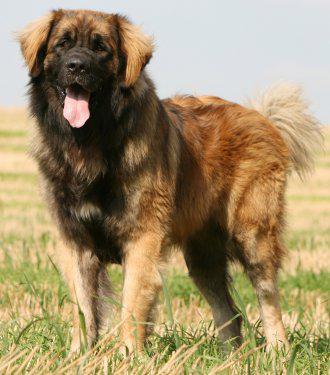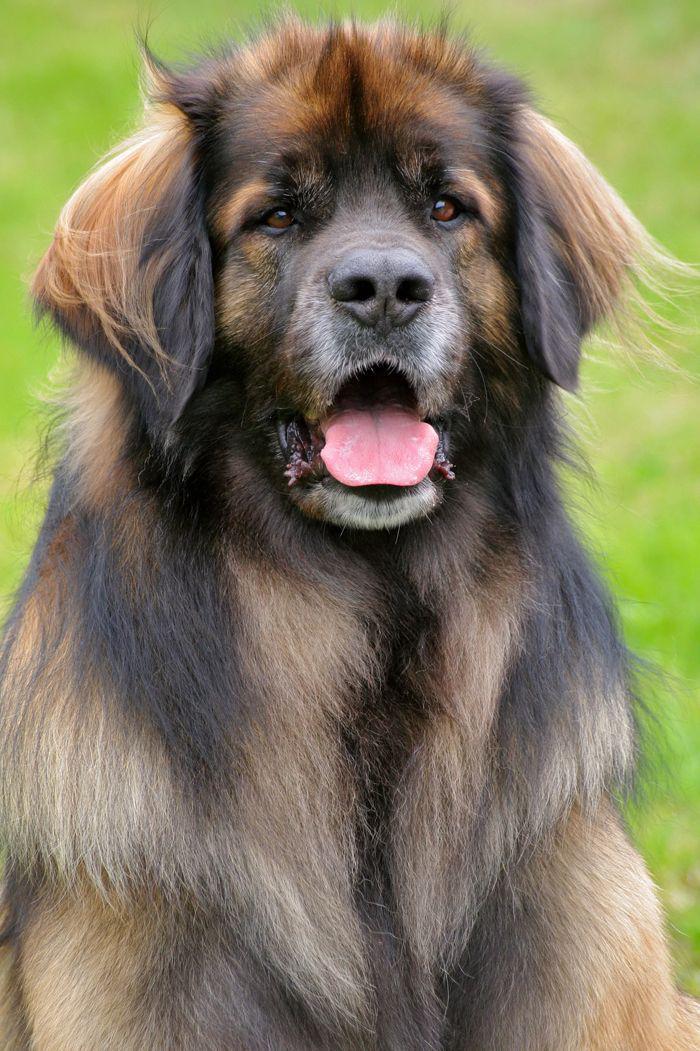The first image is the image on the left, the second image is the image on the right. Given the left and right images, does the statement "At least one of the dogs in the image on the left is shown standing up on the ground." hold true? Answer yes or no. Yes. The first image is the image on the left, the second image is the image on the right. Analyze the images presented: Is the assertion "One image contains just one dog, which is standing on all fours." valid? Answer yes or no. Yes. 